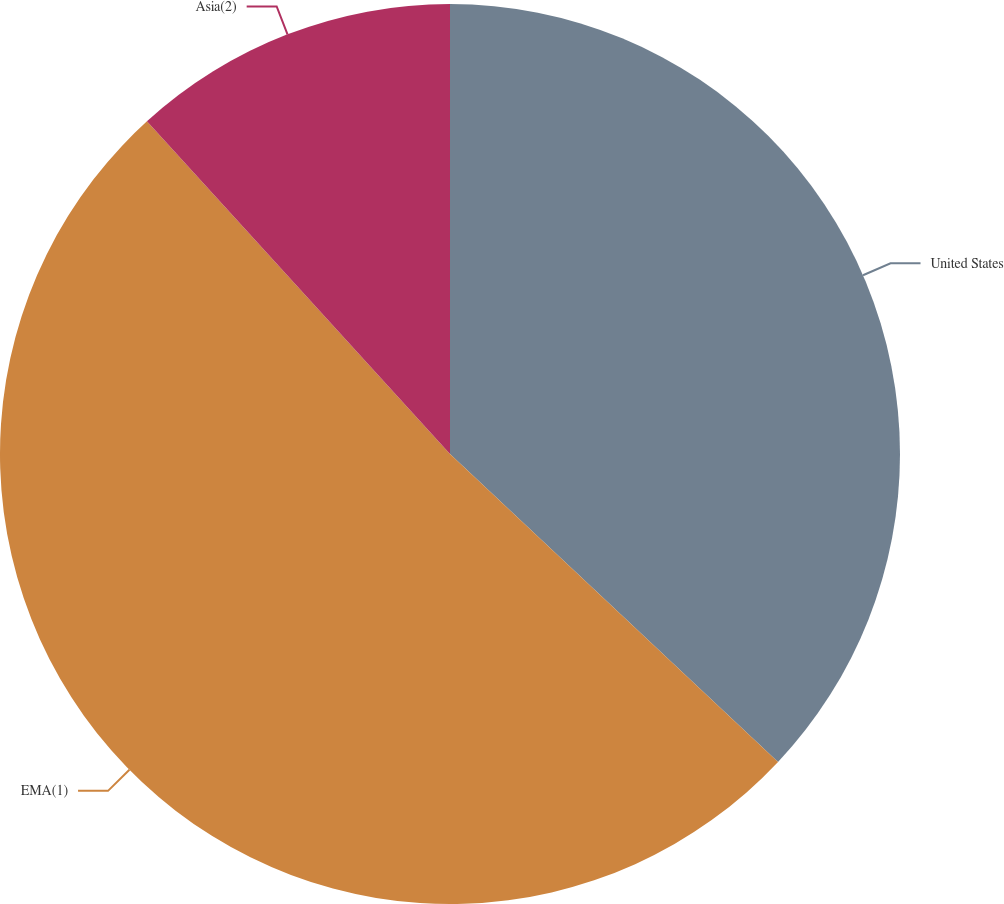Convert chart. <chart><loc_0><loc_0><loc_500><loc_500><pie_chart><fcel>United States<fcel>EMA(1)<fcel>Asia(2)<nl><fcel>37.0%<fcel>51.24%<fcel>11.76%<nl></chart> 